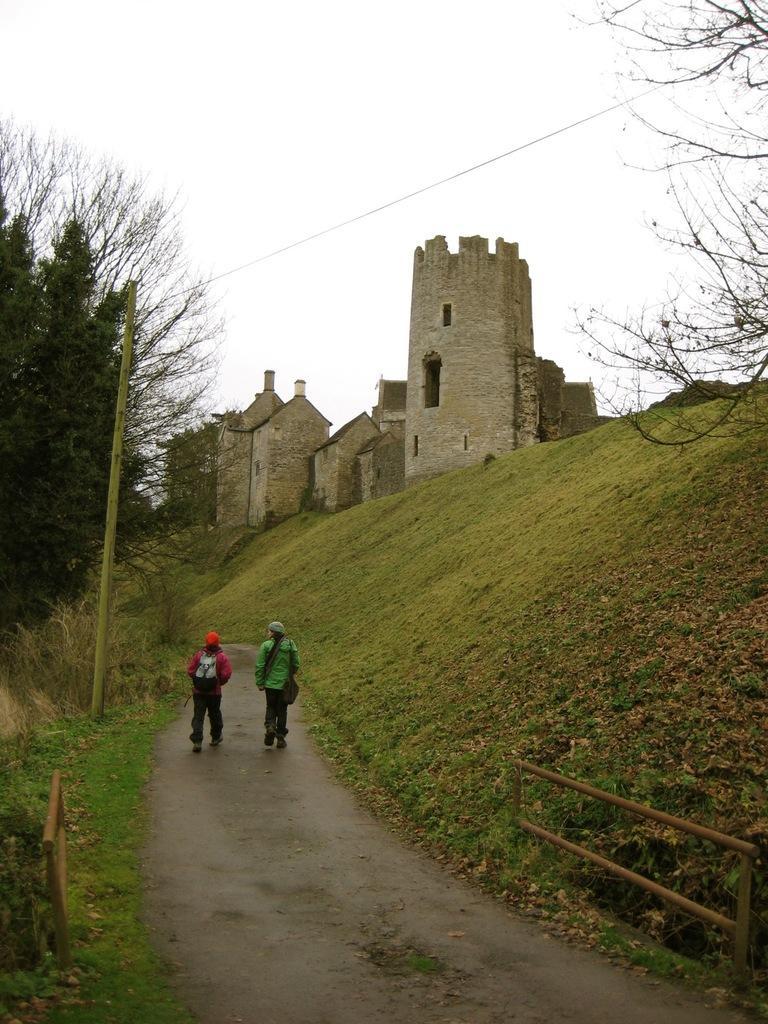Can you describe this image briefly? In this image we can see a building, there are trees, there are two persons walking on the road, there is a pole, there is a wire, there is a fencing, there is a grass, there is a sky. 